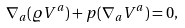Convert formula to latex. <formula><loc_0><loc_0><loc_500><loc_500>\nabla _ { a } ( \varrho V ^ { a } ) + p ( \nabla _ { a } V ^ { a } ) = 0 ,</formula> 